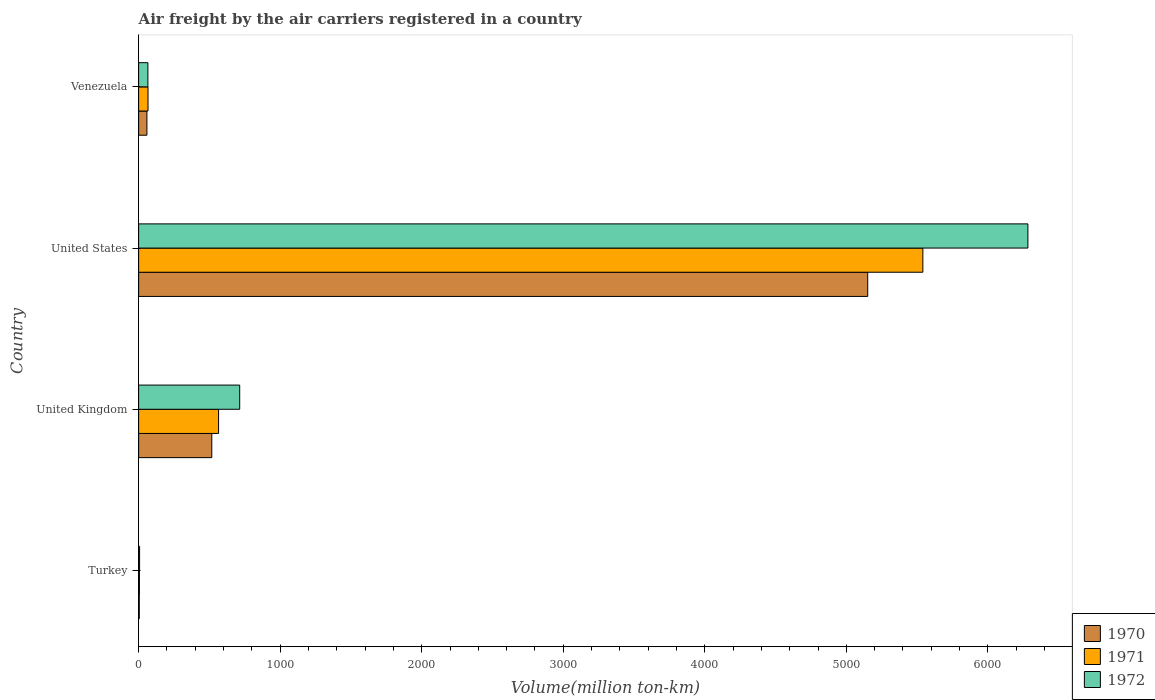How many bars are there on the 2nd tick from the top?
Keep it short and to the point. 3. How many bars are there on the 1st tick from the bottom?
Ensure brevity in your answer.  3. What is the label of the 3rd group of bars from the top?
Give a very brief answer. United Kingdom. What is the volume of the air carriers in 1970 in United States?
Your response must be concise. 5151.2. Across all countries, what is the maximum volume of the air carriers in 1971?
Provide a succinct answer. 5540.8. Across all countries, what is the minimum volume of the air carriers in 1971?
Your answer should be very brief. 5.7. In which country was the volume of the air carriers in 1971 maximum?
Your response must be concise. United States. In which country was the volume of the air carriers in 1970 minimum?
Keep it short and to the point. Turkey. What is the total volume of the air carriers in 1970 in the graph?
Your response must be concise. 5731.3. What is the difference between the volume of the air carriers in 1972 in United Kingdom and that in United States?
Offer a terse response. -5568.9. What is the difference between the volume of the air carriers in 1971 in United States and the volume of the air carriers in 1970 in Turkey?
Give a very brief answer. 5536.2. What is the average volume of the air carriers in 1970 per country?
Keep it short and to the point. 1432.83. In how many countries, is the volume of the air carriers in 1972 greater than 3200 million ton-km?
Your answer should be compact. 1. What is the ratio of the volume of the air carriers in 1972 in Turkey to that in United States?
Give a very brief answer. 0. Is the volume of the air carriers in 1972 in Turkey less than that in Venezuela?
Offer a terse response. Yes. What is the difference between the highest and the second highest volume of the air carriers in 1970?
Your answer should be compact. 4634.3. What is the difference between the highest and the lowest volume of the air carriers in 1971?
Your response must be concise. 5535.1. Is the sum of the volume of the air carriers in 1972 in United States and Venezuela greater than the maximum volume of the air carriers in 1970 across all countries?
Your response must be concise. Yes. What does the 1st bar from the top in United States represents?
Your answer should be very brief. 1972. Is it the case that in every country, the sum of the volume of the air carriers in 1971 and volume of the air carriers in 1970 is greater than the volume of the air carriers in 1972?
Keep it short and to the point. Yes. What is the difference between two consecutive major ticks on the X-axis?
Offer a very short reply. 1000. Does the graph contain grids?
Provide a short and direct response. No. Where does the legend appear in the graph?
Provide a short and direct response. Bottom right. What is the title of the graph?
Your response must be concise. Air freight by the air carriers registered in a country. Does "2003" appear as one of the legend labels in the graph?
Give a very brief answer. No. What is the label or title of the X-axis?
Provide a succinct answer. Volume(million ton-km). What is the label or title of the Y-axis?
Your answer should be very brief. Country. What is the Volume(million ton-km) of 1970 in Turkey?
Your answer should be compact. 4.6. What is the Volume(million ton-km) in 1971 in Turkey?
Offer a very short reply. 5.7. What is the Volume(million ton-km) of 1972 in Turkey?
Provide a succinct answer. 6.8. What is the Volume(million ton-km) in 1970 in United Kingdom?
Keep it short and to the point. 516.9. What is the Volume(million ton-km) of 1971 in United Kingdom?
Keep it short and to the point. 564.9. What is the Volume(million ton-km) of 1972 in United Kingdom?
Give a very brief answer. 714.1. What is the Volume(million ton-km) of 1970 in United States?
Keep it short and to the point. 5151.2. What is the Volume(million ton-km) in 1971 in United States?
Give a very brief answer. 5540.8. What is the Volume(million ton-km) in 1972 in United States?
Provide a succinct answer. 6283. What is the Volume(million ton-km) in 1970 in Venezuela?
Ensure brevity in your answer.  58.6. What is the Volume(million ton-km) of 1971 in Venezuela?
Provide a succinct answer. 66.3. What is the Volume(million ton-km) in 1972 in Venezuela?
Make the answer very short. 65.5. Across all countries, what is the maximum Volume(million ton-km) in 1970?
Your response must be concise. 5151.2. Across all countries, what is the maximum Volume(million ton-km) in 1971?
Your answer should be very brief. 5540.8. Across all countries, what is the maximum Volume(million ton-km) of 1972?
Provide a succinct answer. 6283. Across all countries, what is the minimum Volume(million ton-km) of 1970?
Your answer should be compact. 4.6. Across all countries, what is the minimum Volume(million ton-km) of 1971?
Offer a terse response. 5.7. Across all countries, what is the minimum Volume(million ton-km) in 1972?
Your answer should be very brief. 6.8. What is the total Volume(million ton-km) of 1970 in the graph?
Give a very brief answer. 5731.3. What is the total Volume(million ton-km) of 1971 in the graph?
Provide a short and direct response. 6177.7. What is the total Volume(million ton-km) in 1972 in the graph?
Your answer should be compact. 7069.4. What is the difference between the Volume(million ton-km) in 1970 in Turkey and that in United Kingdom?
Your answer should be very brief. -512.3. What is the difference between the Volume(million ton-km) in 1971 in Turkey and that in United Kingdom?
Provide a succinct answer. -559.2. What is the difference between the Volume(million ton-km) of 1972 in Turkey and that in United Kingdom?
Provide a succinct answer. -707.3. What is the difference between the Volume(million ton-km) of 1970 in Turkey and that in United States?
Offer a terse response. -5146.6. What is the difference between the Volume(million ton-km) of 1971 in Turkey and that in United States?
Your answer should be very brief. -5535.1. What is the difference between the Volume(million ton-km) of 1972 in Turkey and that in United States?
Keep it short and to the point. -6276.2. What is the difference between the Volume(million ton-km) of 1970 in Turkey and that in Venezuela?
Your answer should be compact. -54. What is the difference between the Volume(million ton-km) in 1971 in Turkey and that in Venezuela?
Offer a very short reply. -60.6. What is the difference between the Volume(million ton-km) of 1972 in Turkey and that in Venezuela?
Provide a succinct answer. -58.7. What is the difference between the Volume(million ton-km) in 1970 in United Kingdom and that in United States?
Make the answer very short. -4634.3. What is the difference between the Volume(million ton-km) in 1971 in United Kingdom and that in United States?
Provide a short and direct response. -4975.9. What is the difference between the Volume(million ton-km) in 1972 in United Kingdom and that in United States?
Offer a terse response. -5568.9. What is the difference between the Volume(million ton-km) in 1970 in United Kingdom and that in Venezuela?
Your answer should be very brief. 458.3. What is the difference between the Volume(million ton-km) in 1971 in United Kingdom and that in Venezuela?
Your response must be concise. 498.6. What is the difference between the Volume(million ton-km) in 1972 in United Kingdom and that in Venezuela?
Ensure brevity in your answer.  648.6. What is the difference between the Volume(million ton-km) of 1970 in United States and that in Venezuela?
Your answer should be very brief. 5092.6. What is the difference between the Volume(million ton-km) of 1971 in United States and that in Venezuela?
Provide a short and direct response. 5474.5. What is the difference between the Volume(million ton-km) of 1972 in United States and that in Venezuela?
Provide a short and direct response. 6217.5. What is the difference between the Volume(million ton-km) of 1970 in Turkey and the Volume(million ton-km) of 1971 in United Kingdom?
Your answer should be very brief. -560.3. What is the difference between the Volume(million ton-km) in 1970 in Turkey and the Volume(million ton-km) in 1972 in United Kingdom?
Make the answer very short. -709.5. What is the difference between the Volume(million ton-km) in 1971 in Turkey and the Volume(million ton-km) in 1972 in United Kingdom?
Give a very brief answer. -708.4. What is the difference between the Volume(million ton-km) of 1970 in Turkey and the Volume(million ton-km) of 1971 in United States?
Offer a terse response. -5536.2. What is the difference between the Volume(million ton-km) in 1970 in Turkey and the Volume(million ton-km) in 1972 in United States?
Your answer should be compact. -6278.4. What is the difference between the Volume(million ton-km) in 1971 in Turkey and the Volume(million ton-km) in 1972 in United States?
Offer a very short reply. -6277.3. What is the difference between the Volume(million ton-km) in 1970 in Turkey and the Volume(million ton-km) in 1971 in Venezuela?
Provide a succinct answer. -61.7. What is the difference between the Volume(million ton-km) in 1970 in Turkey and the Volume(million ton-km) in 1972 in Venezuela?
Give a very brief answer. -60.9. What is the difference between the Volume(million ton-km) of 1971 in Turkey and the Volume(million ton-km) of 1972 in Venezuela?
Your response must be concise. -59.8. What is the difference between the Volume(million ton-km) of 1970 in United Kingdom and the Volume(million ton-km) of 1971 in United States?
Offer a very short reply. -5023.9. What is the difference between the Volume(million ton-km) in 1970 in United Kingdom and the Volume(million ton-km) in 1972 in United States?
Ensure brevity in your answer.  -5766.1. What is the difference between the Volume(million ton-km) in 1971 in United Kingdom and the Volume(million ton-km) in 1972 in United States?
Provide a short and direct response. -5718.1. What is the difference between the Volume(million ton-km) in 1970 in United Kingdom and the Volume(million ton-km) in 1971 in Venezuela?
Provide a succinct answer. 450.6. What is the difference between the Volume(million ton-km) in 1970 in United Kingdom and the Volume(million ton-km) in 1972 in Venezuela?
Your response must be concise. 451.4. What is the difference between the Volume(million ton-km) of 1971 in United Kingdom and the Volume(million ton-km) of 1972 in Venezuela?
Your answer should be very brief. 499.4. What is the difference between the Volume(million ton-km) of 1970 in United States and the Volume(million ton-km) of 1971 in Venezuela?
Offer a terse response. 5084.9. What is the difference between the Volume(million ton-km) of 1970 in United States and the Volume(million ton-km) of 1972 in Venezuela?
Provide a succinct answer. 5085.7. What is the difference between the Volume(million ton-km) in 1971 in United States and the Volume(million ton-km) in 1972 in Venezuela?
Your answer should be very brief. 5475.3. What is the average Volume(million ton-km) in 1970 per country?
Provide a short and direct response. 1432.83. What is the average Volume(million ton-km) in 1971 per country?
Ensure brevity in your answer.  1544.42. What is the average Volume(million ton-km) in 1972 per country?
Your answer should be compact. 1767.35. What is the difference between the Volume(million ton-km) of 1970 and Volume(million ton-km) of 1971 in United Kingdom?
Offer a terse response. -48. What is the difference between the Volume(million ton-km) of 1970 and Volume(million ton-km) of 1972 in United Kingdom?
Offer a very short reply. -197.2. What is the difference between the Volume(million ton-km) in 1971 and Volume(million ton-km) in 1972 in United Kingdom?
Keep it short and to the point. -149.2. What is the difference between the Volume(million ton-km) of 1970 and Volume(million ton-km) of 1971 in United States?
Provide a short and direct response. -389.6. What is the difference between the Volume(million ton-km) in 1970 and Volume(million ton-km) in 1972 in United States?
Provide a short and direct response. -1131.8. What is the difference between the Volume(million ton-km) of 1971 and Volume(million ton-km) of 1972 in United States?
Provide a short and direct response. -742.2. What is the difference between the Volume(million ton-km) in 1970 and Volume(million ton-km) in 1971 in Venezuela?
Your response must be concise. -7.7. What is the difference between the Volume(million ton-km) of 1970 and Volume(million ton-km) of 1972 in Venezuela?
Give a very brief answer. -6.9. What is the ratio of the Volume(million ton-km) in 1970 in Turkey to that in United Kingdom?
Your answer should be very brief. 0.01. What is the ratio of the Volume(million ton-km) in 1971 in Turkey to that in United Kingdom?
Give a very brief answer. 0.01. What is the ratio of the Volume(million ton-km) of 1972 in Turkey to that in United Kingdom?
Make the answer very short. 0.01. What is the ratio of the Volume(million ton-km) of 1970 in Turkey to that in United States?
Provide a short and direct response. 0. What is the ratio of the Volume(million ton-km) of 1972 in Turkey to that in United States?
Provide a short and direct response. 0. What is the ratio of the Volume(million ton-km) of 1970 in Turkey to that in Venezuela?
Ensure brevity in your answer.  0.08. What is the ratio of the Volume(million ton-km) in 1971 in Turkey to that in Venezuela?
Provide a succinct answer. 0.09. What is the ratio of the Volume(million ton-km) in 1972 in Turkey to that in Venezuela?
Offer a terse response. 0.1. What is the ratio of the Volume(million ton-km) of 1970 in United Kingdom to that in United States?
Your response must be concise. 0.1. What is the ratio of the Volume(million ton-km) in 1971 in United Kingdom to that in United States?
Keep it short and to the point. 0.1. What is the ratio of the Volume(million ton-km) in 1972 in United Kingdom to that in United States?
Provide a succinct answer. 0.11. What is the ratio of the Volume(million ton-km) of 1970 in United Kingdom to that in Venezuela?
Give a very brief answer. 8.82. What is the ratio of the Volume(million ton-km) in 1971 in United Kingdom to that in Venezuela?
Offer a terse response. 8.52. What is the ratio of the Volume(million ton-km) in 1972 in United Kingdom to that in Venezuela?
Your response must be concise. 10.9. What is the ratio of the Volume(million ton-km) in 1970 in United States to that in Venezuela?
Ensure brevity in your answer.  87.9. What is the ratio of the Volume(million ton-km) in 1971 in United States to that in Venezuela?
Offer a very short reply. 83.57. What is the ratio of the Volume(million ton-km) of 1972 in United States to that in Venezuela?
Your response must be concise. 95.92. What is the difference between the highest and the second highest Volume(million ton-km) in 1970?
Make the answer very short. 4634.3. What is the difference between the highest and the second highest Volume(million ton-km) in 1971?
Offer a very short reply. 4975.9. What is the difference between the highest and the second highest Volume(million ton-km) of 1972?
Your answer should be compact. 5568.9. What is the difference between the highest and the lowest Volume(million ton-km) of 1970?
Keep it short and to the point. 5146.6. What is the difference between the highest and the lowest Volume(million ton-km) in 1971?
Your answer should be very brief. 5535.1. What is the difference between the highest and the lowest Volume(million ton-km) of 1972?
Your answer should be compact. 6276.2. 